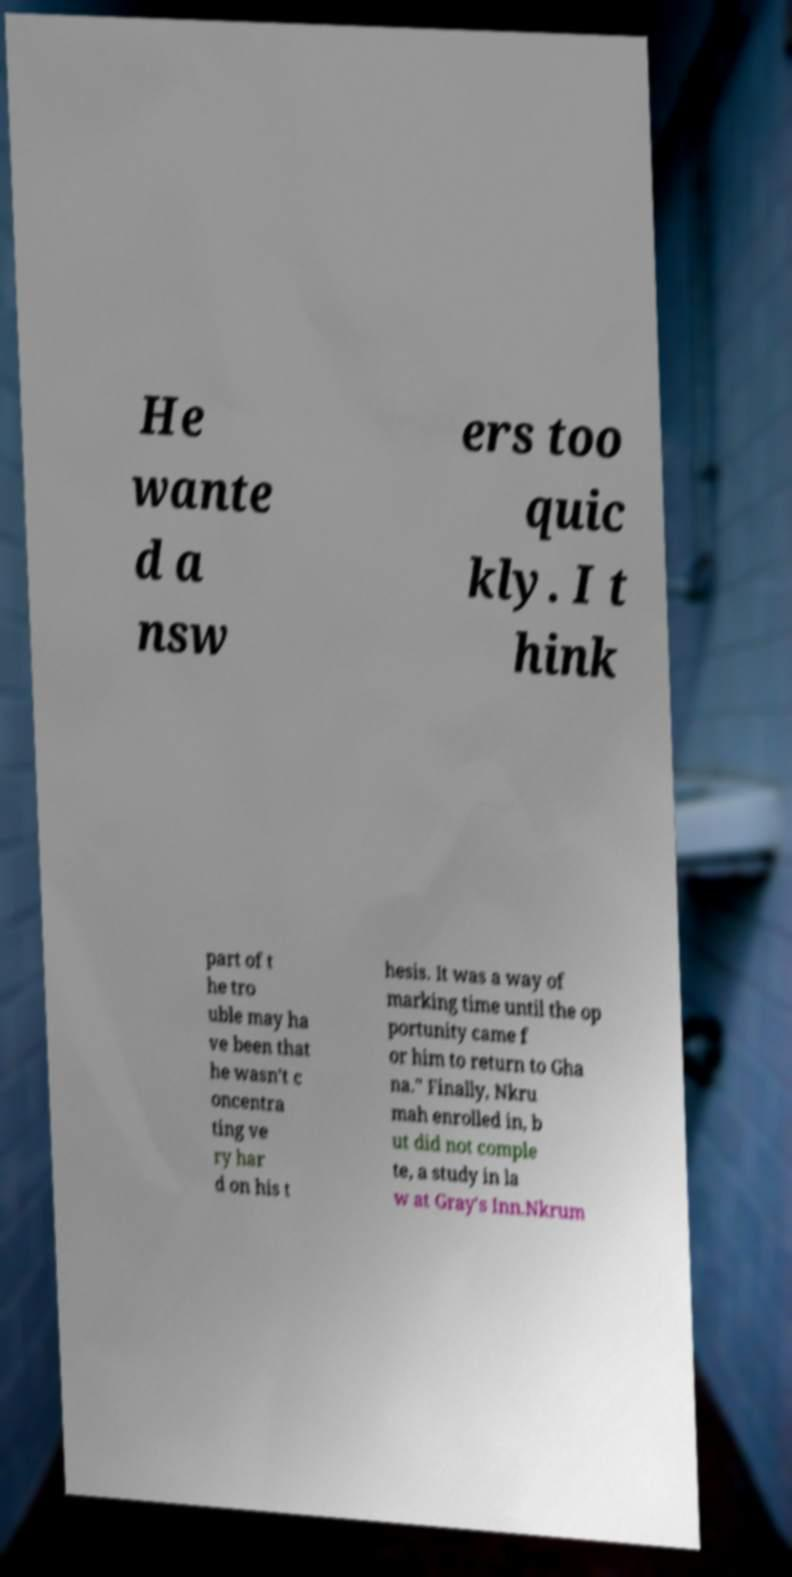Please identify and transcribe the text found in this image. He wante d a nsw ers too quic kly. I t hink part of t he tro uble may ha ve been that he wasn't c oncentra ting ve ry har d on his t hesis. It was a way of marking time until the op portunity came f or him to return to Gha na." Finally, Nkru mah enrolled in, b ut did not comple te, a study in la w at Gray's Inn.Nkrum 